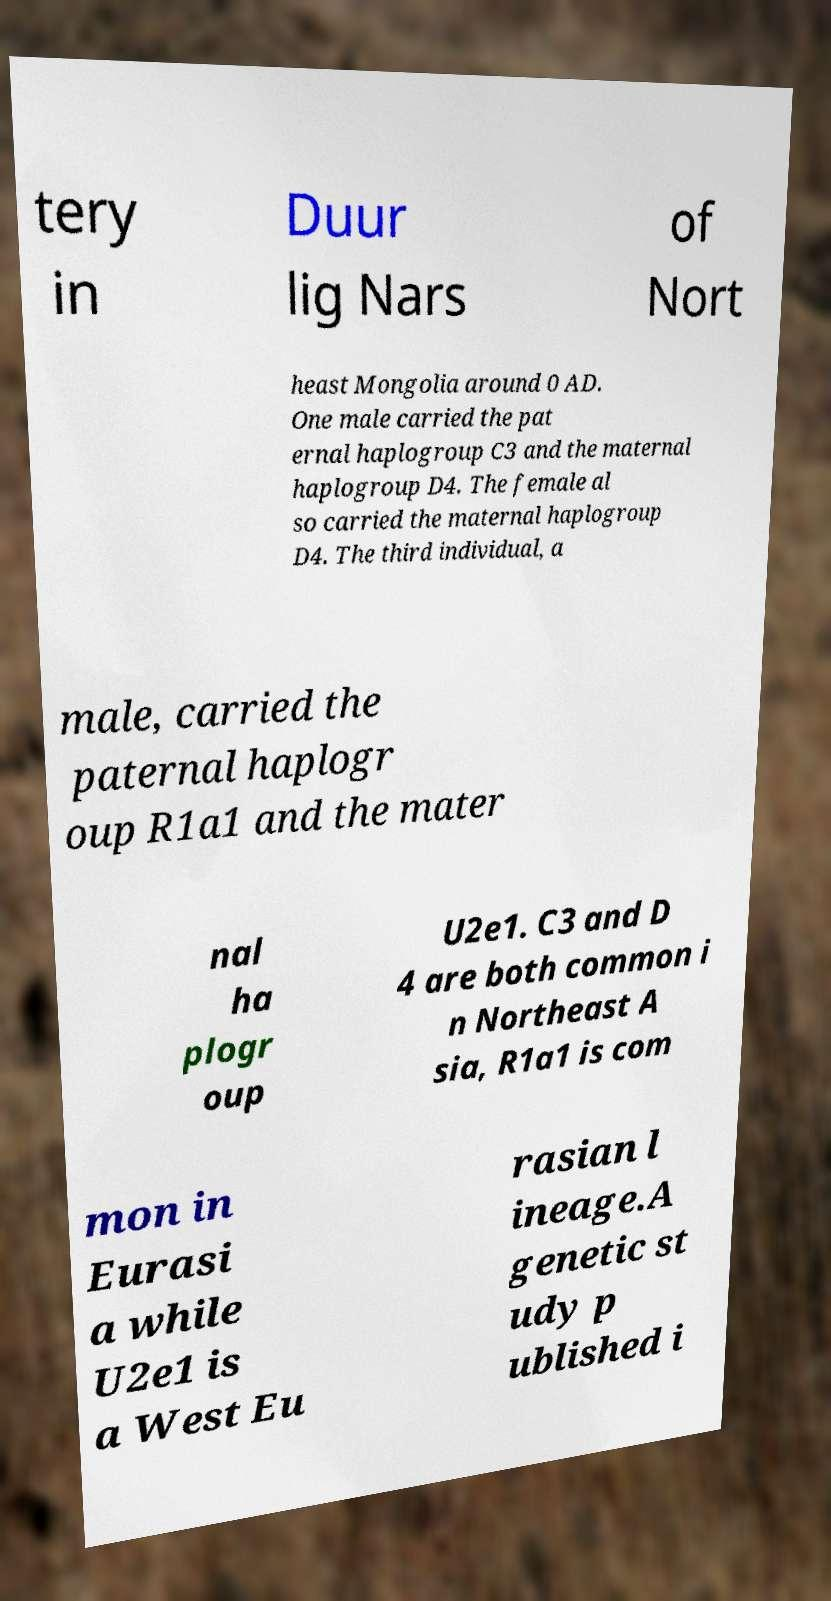Can you accurately transcribe the text from the provided image for me? tery in Duur lig Nars of Nort heast Mongolia around 0 AD. One male carried the pat ernal haplogroup C3 and the maternal haplogroup D4. The female al so carried the maternal haplogroup D4. The third individual, a male, carried the paternal haplogr oup R1a1 and the mater nal ha plogr oup U2e1. C3 and D 4 are both common i n Northeast A sia, R1a1 is com mon in Eurasi a while U2e1 is a West Eu rasian l ineage.A genetic st udy p ublished i 